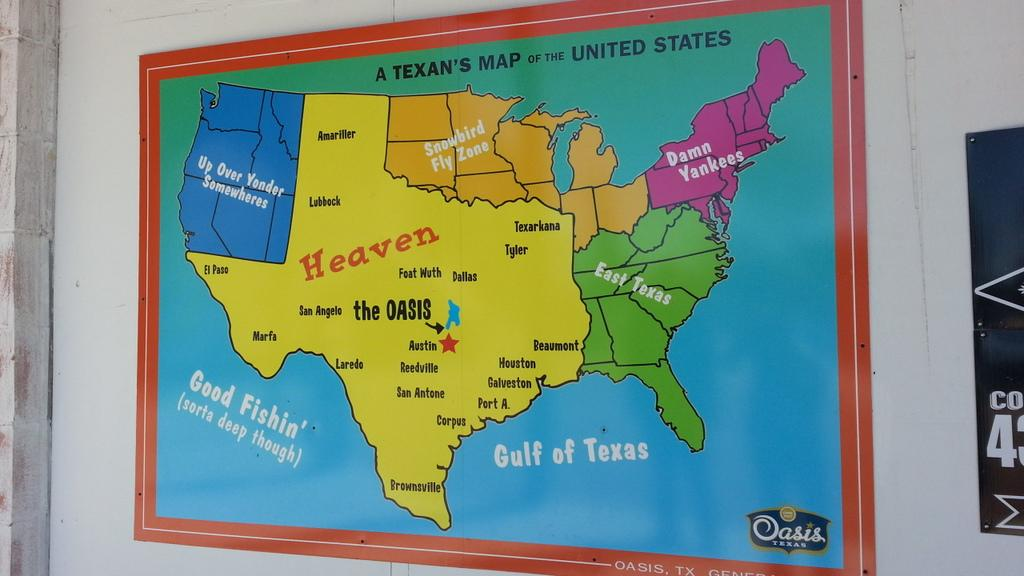<image>
Share a concise interpretation of the image provided. A humorous map drawn from a Texans' point of view. 